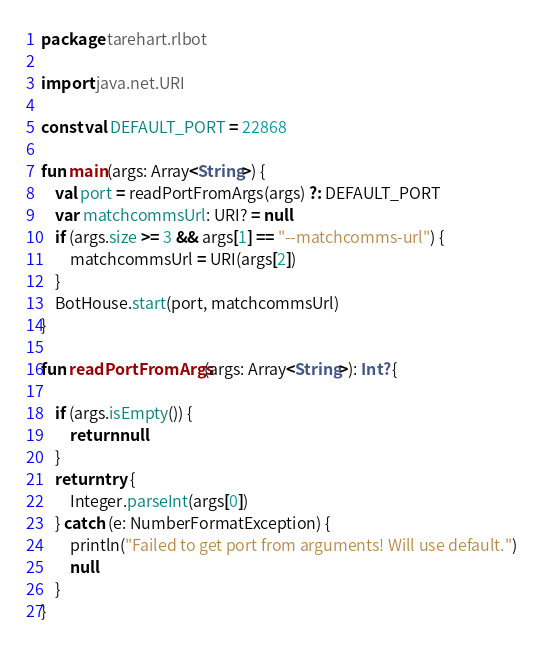<code> <loc_0><loc_0><loc_500><loc_500><_Kotlin_>package tarehart.rlbot

import java.net.URI

const val DEFAULT_PORT = 22868

fun main(args: Array<String>) {
    val port = readPortFromArgs(args) ?: DEFAULT_PORT
    var matchcommsUrl: URI? = null
    if (args.size >= 3 && args[1] == "--matchcomms-url") {
        matchcommsUrl = URI(args[2])
    }
    BotHouse.start(port, matchcommsUrl)
}

fun readPortFromArgs(args: Array<String>): Int? {

    if (args.isEmpty()) {
        return null
    }
    return try {
        Integer.parseInt(args[0])
    } catch (e: NumberFormatException) {
        println("Failed to get port from arguments! Will use default.")
        null
    }
}
</code> 